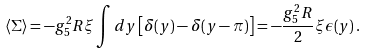Convert formula to latex. <formula><loc_0><loc_0><loc_500><loc_500>\langle \Sigma \rangle = - g ^ { 2 } _ { 5 } R \xi \int d y \left [ \delta ( y ) - \delta ( y - \pi ) \right ] = - \frac { g ^ { 2 } _ { 5 } R } { 2 } \xi \epsilon ( y ) \, .</formula> 